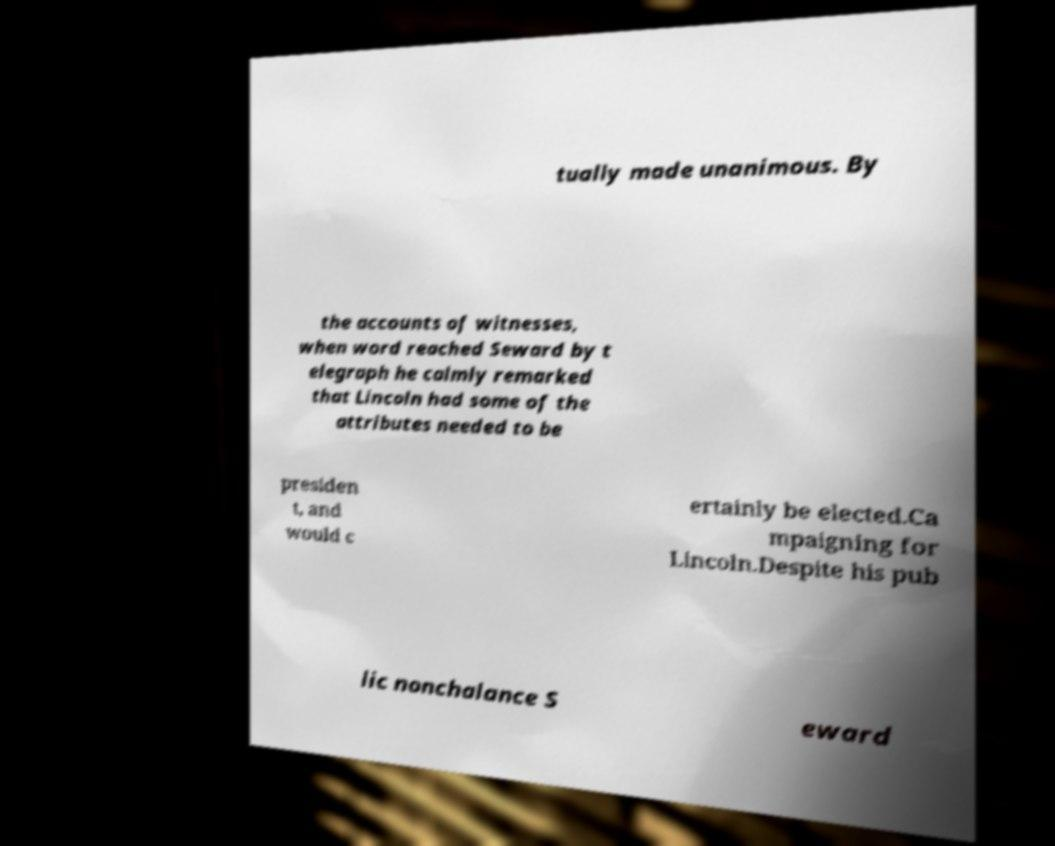I need the written content from this picture converted into text. Can you do that? tually made unanimous. By the accounts of witnesses, when word reached Seward by t elegraph he calmly remarked that Lincoln had some of the attributes needed to be presiden t, and would c ertainly be elected.Ca mpaigning for Lincoln.Despite his pub lic nonchalance S eward 